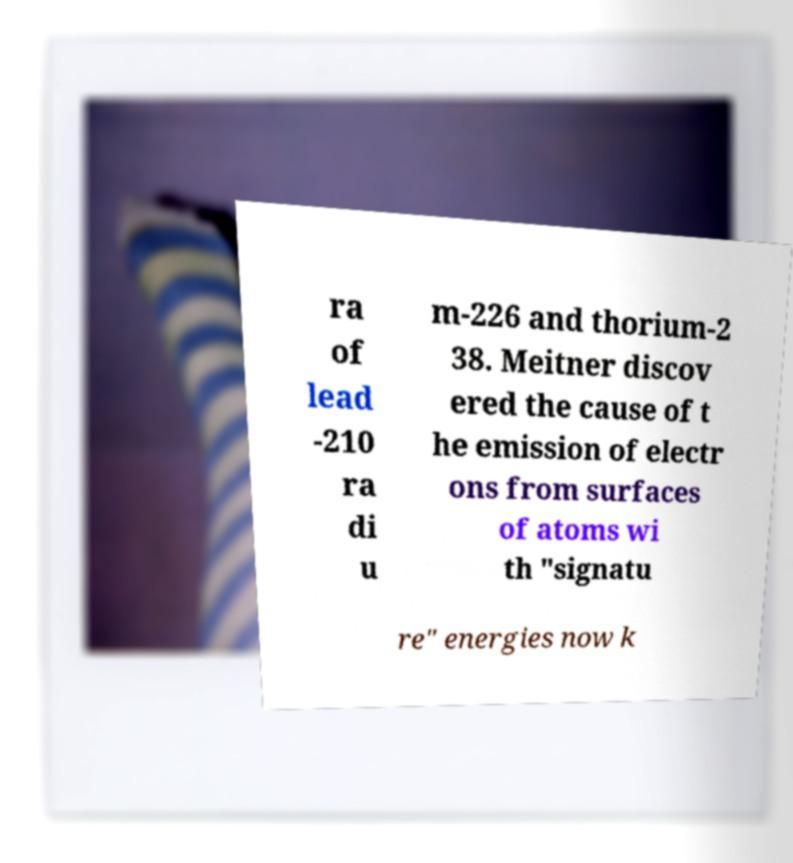Could you extract and type out the text from this image? ra of lead -210 ra di u m-226 and thorium-2 38. Meitner discov ered the cause of t he emission of electr ons from surfaces of atoms wi th "signatu re" energies now k 